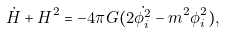<formula> <loc_0><loc_0><loc_500><loc_500>\dot { H } + H ^ { 2 } = - 4 \pi G ( 2 \dot { \phi ^ { 2 } _ { i } } - m ^ { 2 } \phi ^ { 2 } _ { i } ) ,</formula> 